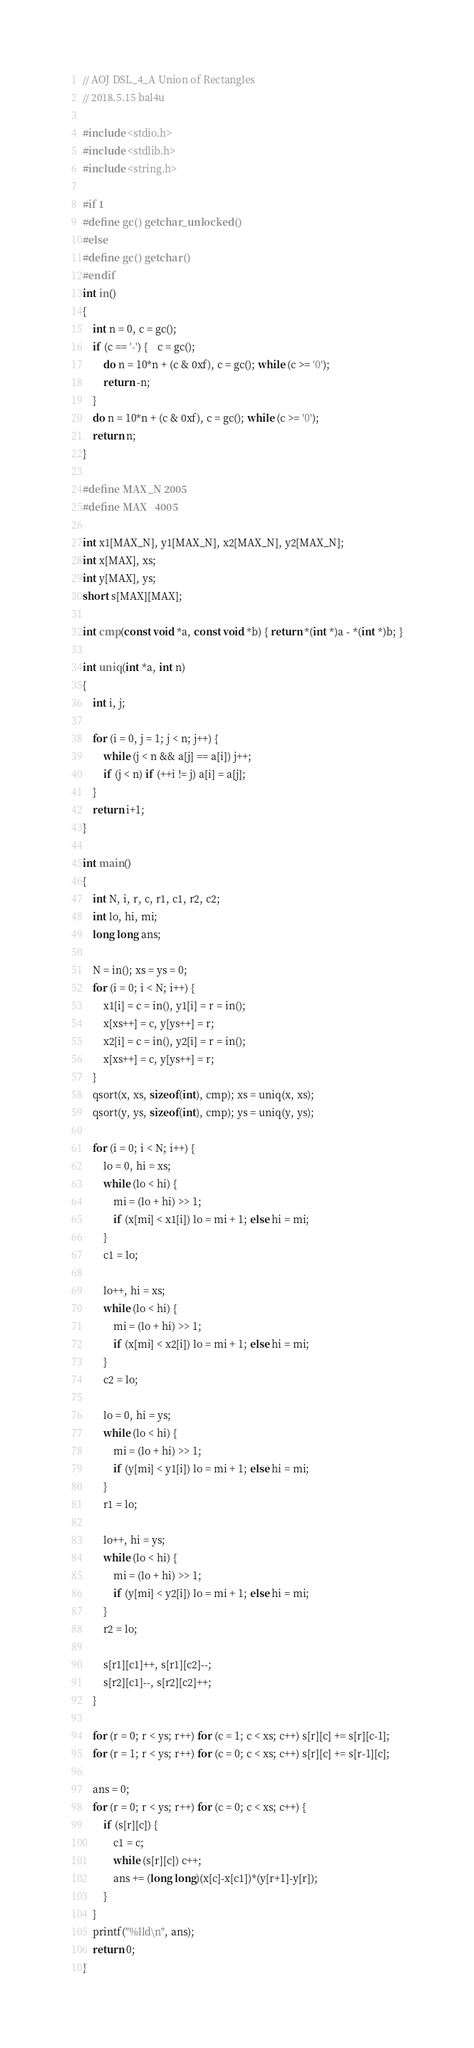<code> <loc_0><loc_0><loc_500><loc_500><_C_>// AOJ DSL_4_A Union of Rectangles
// 2018.5.15 bal4u

#include <stdio.h>
#include <stdlib.h>
#include <string.h>

#if 1
#define gc() getchar_unlocked()
#else
#define gc() getchar()
#endif
int in()
{
	int n = 0, c = gc();
	if (c == '-') {	c = gc();
		do n = 10*n + (c & 0xf), c = gc(); while (c >= '0');
		return -n;
	}
	do n = 10*n + (c & 0xf), c = gc(); while (c >= '0');
	return n;
}

#define MAX_N 2005
#define MAX   4005

int x1[MAX_N], y1[MAX_N], x2[MAX_N], y2[MAX_N];
int x[MAX], xs;
int y[MAX], ys;
short s[MAX][MAX];

int cmp(const void *a, const void *b) { return *(int *)a - *(int *)b; }

int uniq(int *a, int n)
{
	int i, j;
	
	for (i = 0, j = 1; j < n; j++) {
		while (j < n && a[j] == a[i]) j++;
		if (j < n) if (++i != j) a[i] = a[j];
	}
	return i+1;
}

int main()
{
	int N, i, r, c, r1, c1, r2, c2;
	int lo, hi, mi;
	long long ans;

	N = in(); xs = ys = 0;
	for (i = 0; i < N; i++) {
		x1[i] = c = in(), y1[i] = r = in();
		x[xs++] = c, y[ys++] = r;
		x2[i] = c = in(), y2[i] = r = in();
		x[xs++] = c, y[ys++] = r;
	}
	qsort(x, xs, sizeof(int), cmp); xs = uniq(x, xs);
	qsort(y, ys, sizeof(int), cmp); ys = uniq(y, ys);

	for (i = 0; i < N; i++) {
		lo = 0, hi = xs;
		while (lo < hi) {
			mi = (lo + hi) >> 1;
			if (x[mi] < x1[i]) lo = mi + 1; else hi = mi;
		}
		c1 = lo;
		
		lo++, hi = xs;
		while (lo < hi) {
			mi = (lo + hi) >> 1;
			if (x[mi] < x2[i]) lo = mi + 1; else hi = mi;
		}
		c2 = lo;
		
		lo = 0, hi = ys;
		while (lo < hi) {
			mi = (lo + hi) >> 1;
			if (y[mi] < y1[i]) lo = mi + 1; else hi = mi;
		}
		r1 = lo;
		
		lo++, hi = ys;
		while (lo < hi) {
			mi = (lo + hi) >> 1;
			if (y[mi] < y2[i]) lo = mi + 1; else hi = mi;
		}
		r2 = lo;

		s[r1][c1]++, s[r1][c2]--;
		s[r2][c1]--, s[r2][c2]++;
	}

	for (r = 0; r < ys; r++) for (c = 1; c < xs; c++) s[r][c] += s[r][c-1];
	for (r = 1; r < ys; r++) for (c = 0; c < xs; c++) s[r][c] += s[r-1][c];

	ans = 0;
	for (r = 0; r < ys; r++) for (c = 0; c < xs; c++) {
		if (s[r][c]) {
			c1 = c;
			while (s[r][c]) c++;
			ans += (long long)(x[c]-x[c1])*(y[r+1]-y[r]);
		}
	}
	printf("%lld\n", ans);
	return 0;
}

</code> 